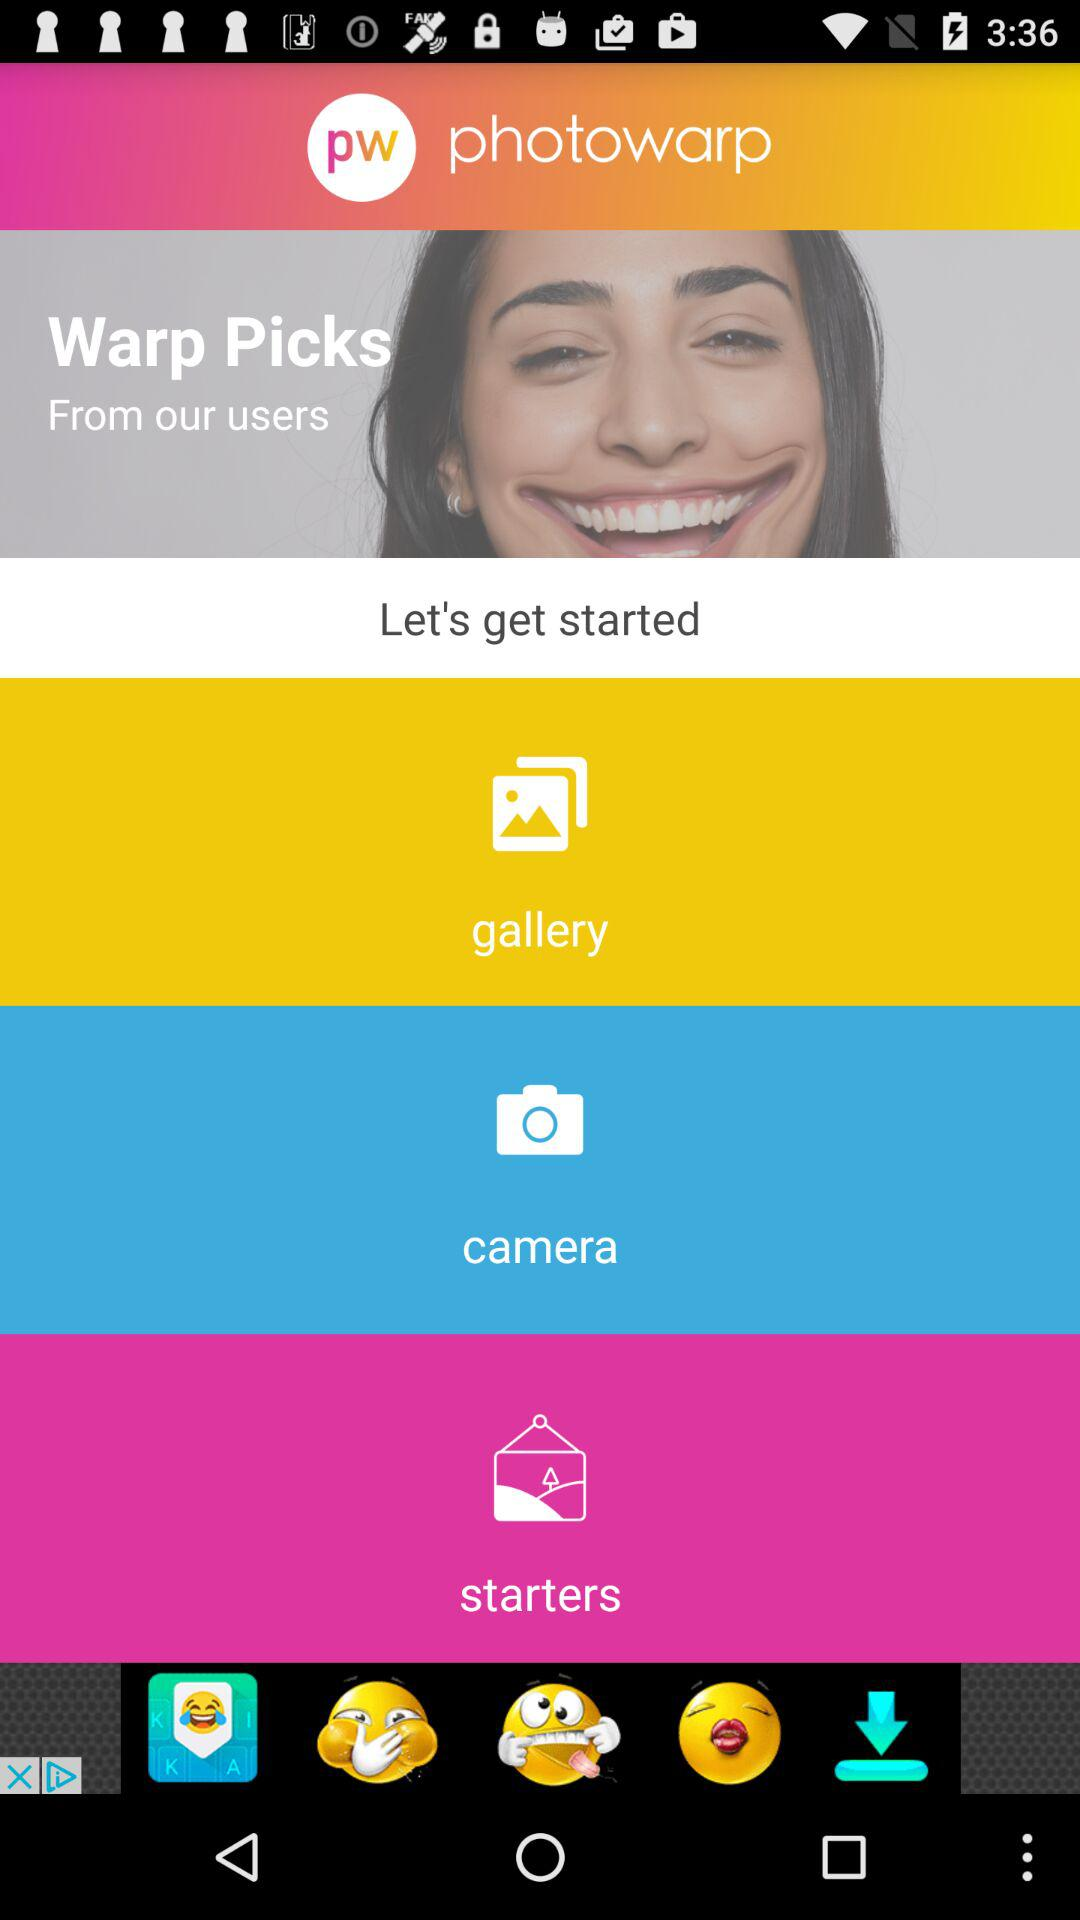What is the name of the application? The name of the application is "photowarp". 